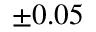<formula> <loc_0><loc_0><loc_500><loc_500>\pm 0 . 0 5</formula> 